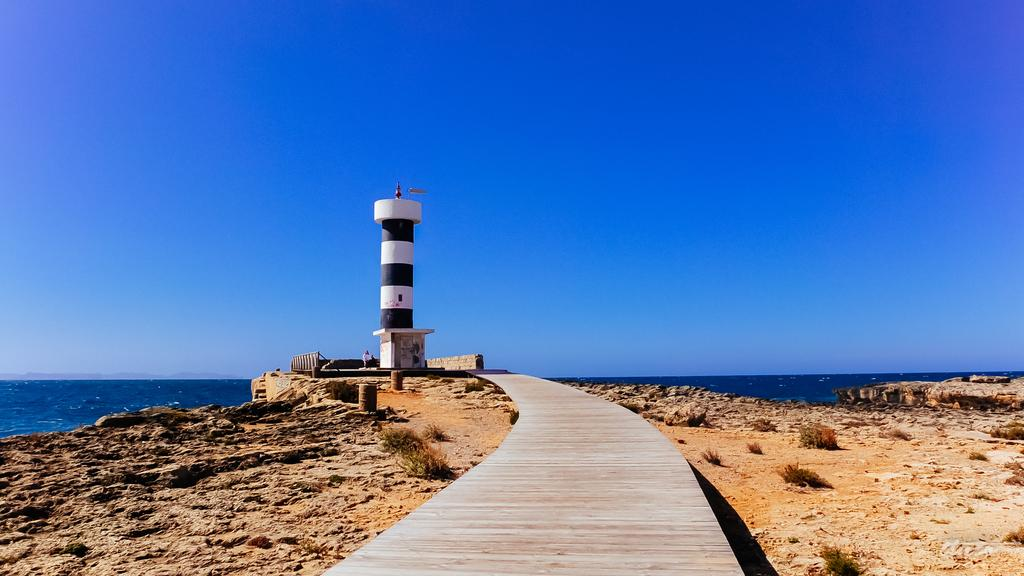What is the main structure in the image? There is a lighthouse in the image. What can be seen near the lighthouse? There is a path in the image. What type of surface is visible in the image? There are stones in the image. What natural element is visible in the image? There is water visible in the image. What is visible above the water and path? The sky is visible in the image. What type of oranges are being used to make the stew in the image? There is no stew or oranges present in the image. Who made the request for the lighthouse to be built in the image? There is no indication of a request or person responsible for the lighthouse in the image. 